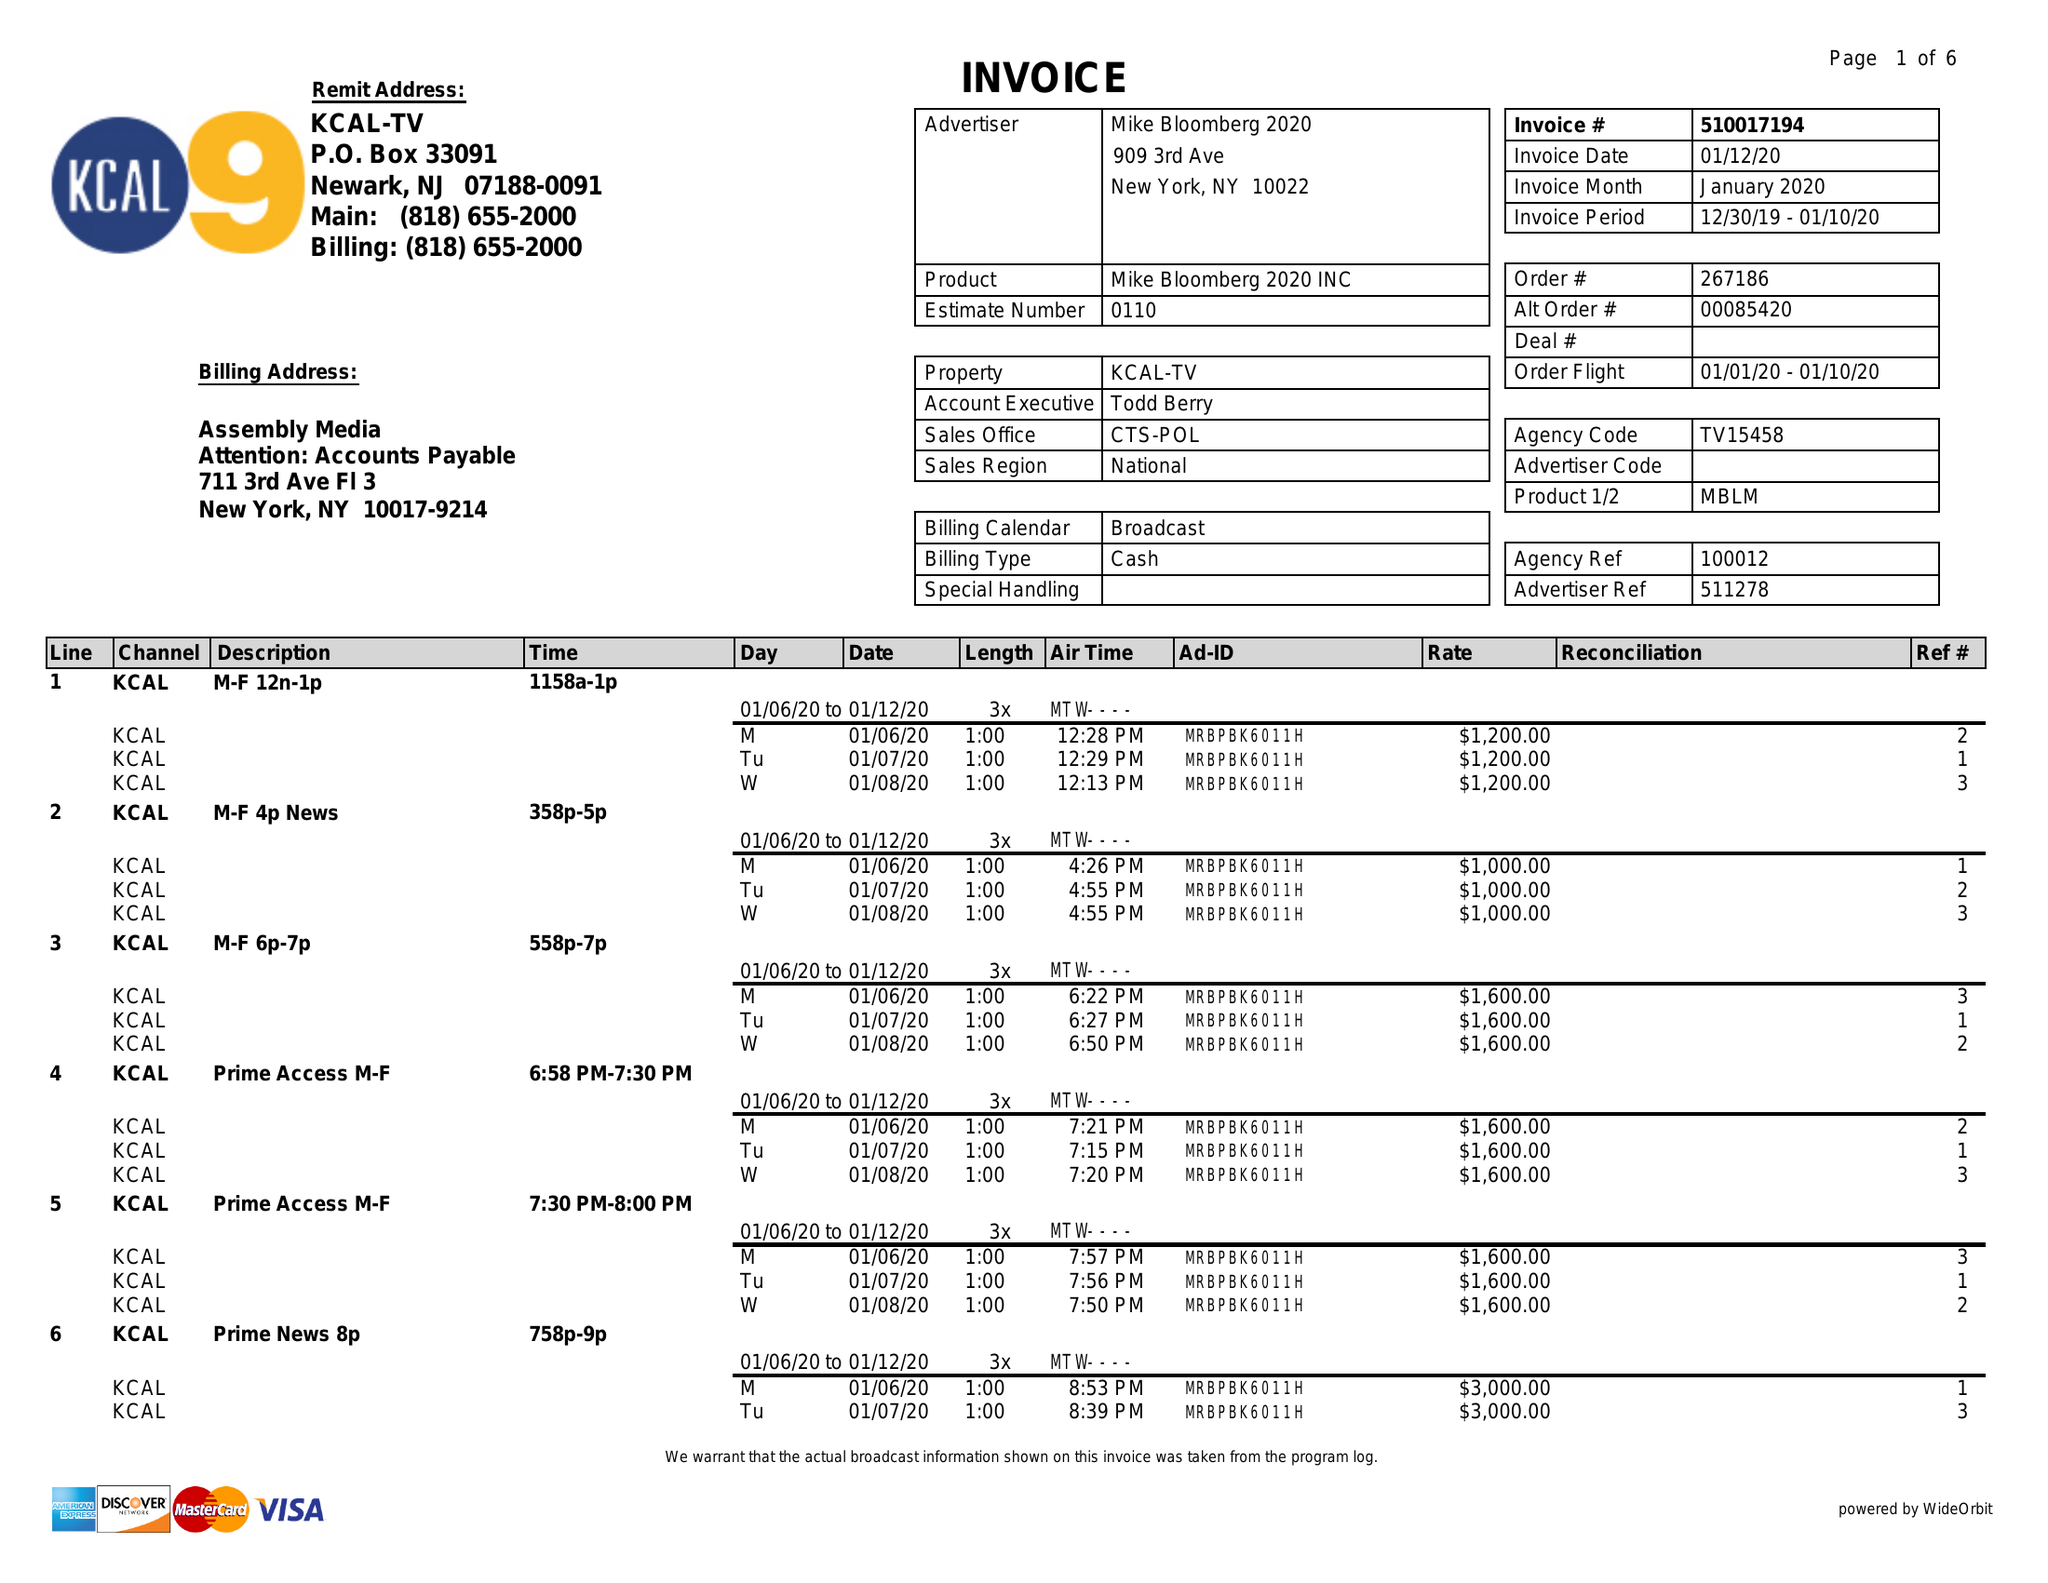What is the value for the flight_to?
Answer the question using a single word or phrase. 01/10/20 